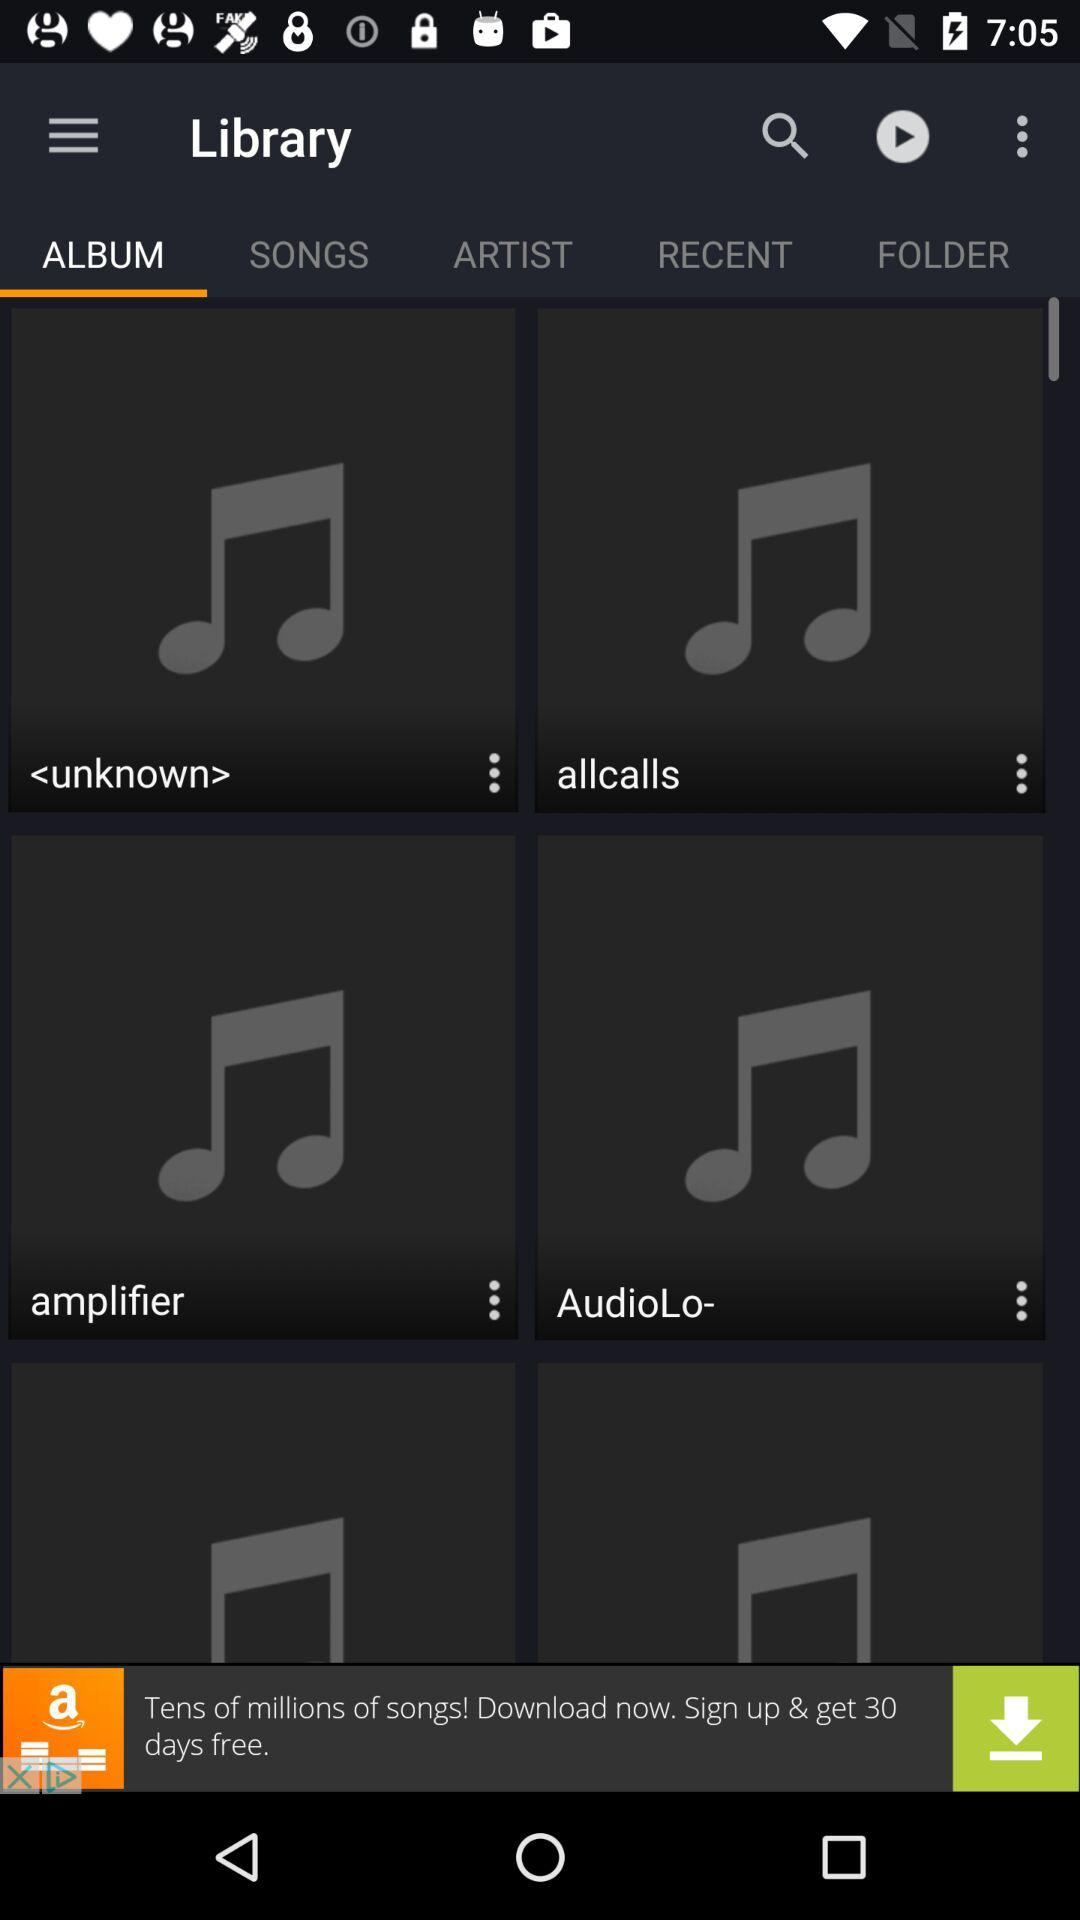What is the app name in the advertisement? The app name in the advertisement is "Amazon Music with Prime Music". 